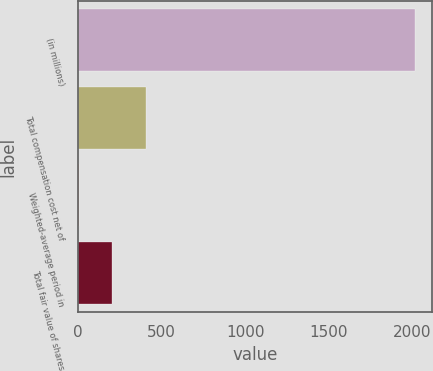<chart> <loc_0><loc_0><loc_500><loc_500><bar_chart><fcel>(in millions)<fcel>Total compensation cost net of<fcel>Weighted-average period in<fcel>Total fair value of shares<nl><fcel>2019<fcel>405.4<fcel>2<fcel>203.7<nl></chart> 